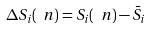<formula> <loc_0><loc_0><loc_500><loc_500>\Delta S _ { i } ( \ n ) = S _ { i } ( \ n ) - \bar { S } _ { i }</formula> 